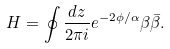<formula> <loc_0><loc_0><loc_500><loc_500>H = \oint \frac { d z } { 2 \pi i } e ^ { - 2 \phi / \alpha } \beta \bar { \beta } .</formula> 